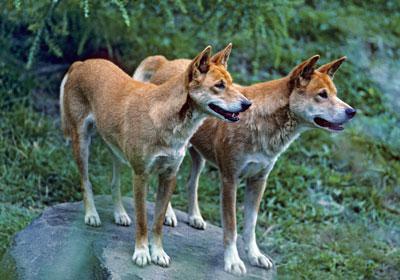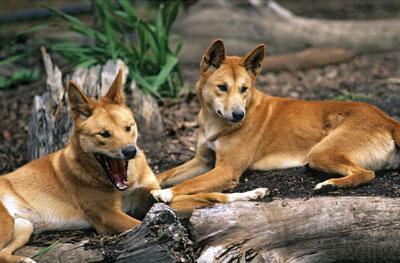The first image is the image on the left, the second image is the image on the right. For the images displayed, is the sentence "There's a total of 4 dogs on both images." factually correct? Answer yes or no. Yes. 